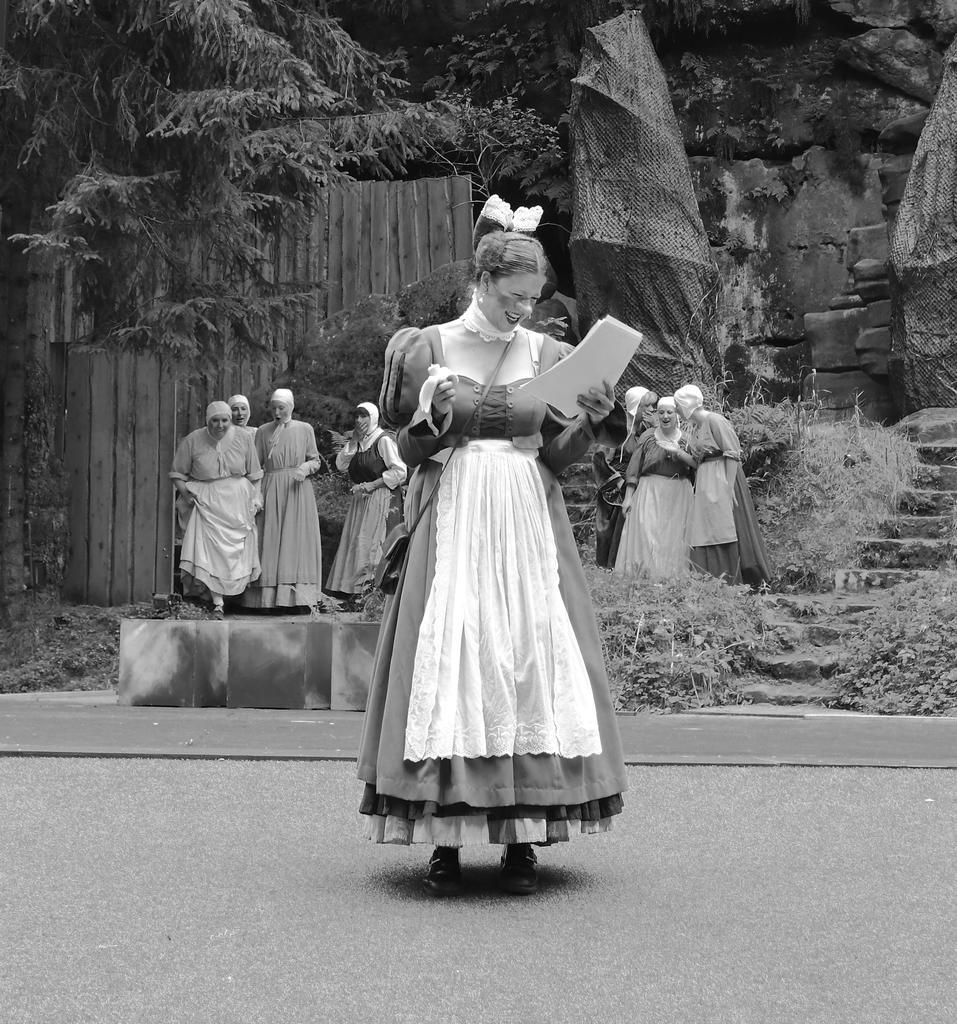Can you describe this image briefly? This is a black and white image. Here I can see a woman wearing a frock, standing on the ground, holding few papers in the hand and smiling by looking at the papers. In the background there are few women standing. At the top I can see few trees and also there is a wall which is made up of wood. On the right side there is a rock and few stairs. 